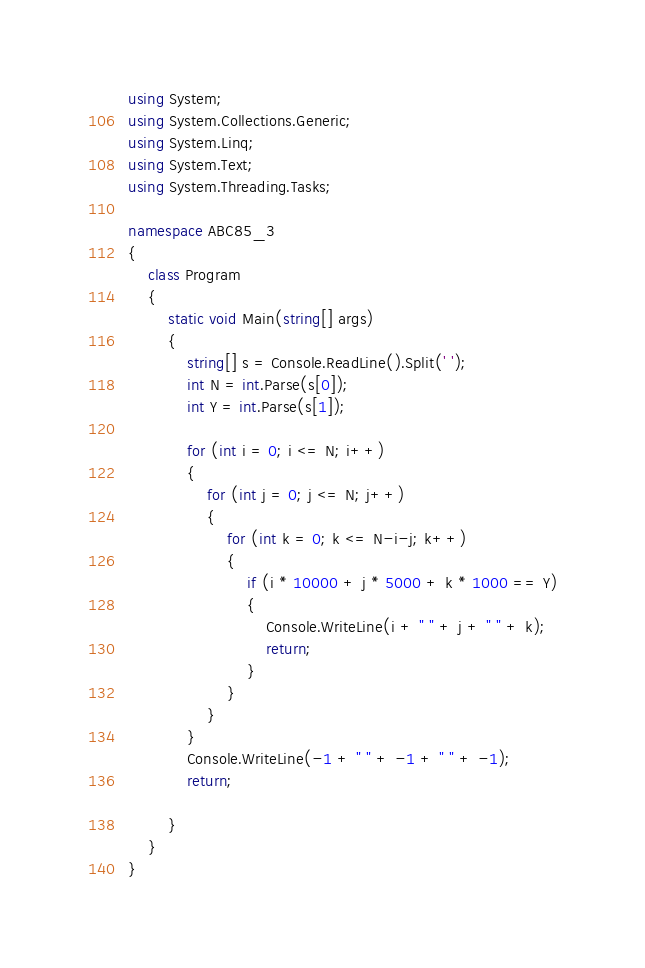<code> <loc_0><loc_0><loc_500><loc_500><_C#_>using System;
using System.Collections.Generic;
using System.Linq;
using System.Text;
using System.Threading.Tasks;

namespace ABC85_3
{
    class Program
    {
        static void Main(string[] args)
        {
            string[] s = Console.ReadLine().Split(' ');
            int N = int.Parse(s[0]);
            int Y = int.Parse(s[1]);

            for (int i = 0; i <= N; i++)
            {
                for (int j = 0; j <= N; j++)
                {
                    for (int k = 0; k <= N-i-j; k++)
                    {
                        if (i * 10000 + j * 5000 + k * 1000 == Y)
                        {
                            Console.WriteLine(i + " " + j + " " + k);
                            return;
                        }
                    }
                }
            }
            Console.WriteLine(-1 + " " + -1 + " " + -1);
            return;

        }
    }
}
</code> 